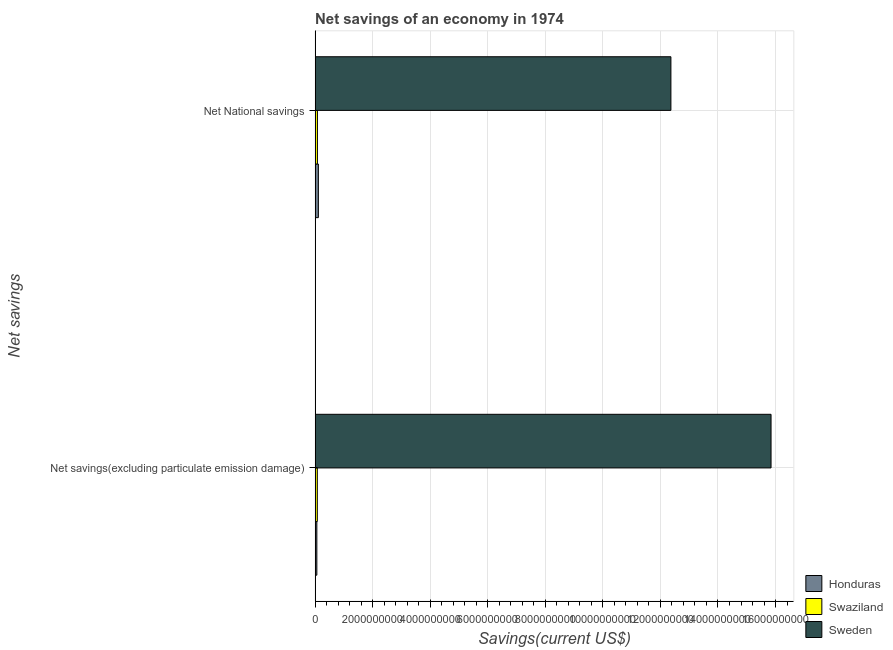Are the number of bars on each tick of the Y-axis equal?
Offer a very short reply. Yes. How many bars are there on the 1st tick from the top?
Provide a short and direct response. 3. How many bars are there on the 1st tick from the bottom?
Make the answer very short. 3. What is the label of the 1st group of bars from the top?
Give a very brief answer. Net National savings. What is the net national savings in Sweden?
Provide a succinct answer. 1.24e+1. Across all countries, what is the maximum net national savings?
Offer a terse response. 1.24e+1. Across all countries, what is the minimum net savings(excluding particulate emission damage)?
Offer a very short reply. 6.03e+07. In which country was the net national savings minimum?
Ensure brevity in your answer.  Swaziland. What is the total net savings(excluding particulate emission damage) in the graph?
Offer a very short reply. 1.60e+1. What is the difference between the net national savings in Honduras and that in Swaziland?
Provide a succinct answer. 3.31e+07. What is the difference between the net national savings in Honduras and the net savings(excluding particulate emission damage) in Sweden?
Your answer should be very brief. -1.57e+1. What is the average net national savings per country?
Provide a succinct answer. 4.19e+09. What is the difference between the net savings(excluding particulate emission damage) and net national savings in Swaziland?
Your response must be concise. -4.00e+06. In how many countries, is the net savings(excluding particulate emission damage) greater than 11600000000 US$?
Your answer should be very brief. 1. What is the ratio of the net savings(excluding particulate emission damage) in Honduras to that in Swaziland?
Your response must be concise. 0.79. Is the net national savings in Honduras less than that in Sweden?
Ensure brevity in your answer.  Yes. In how many countries, is the net savings(excluding particulate emission damage) greater than the average net savings(excluding particulate emission damage) taken over all countries?
Keep it short and to the point. 1. What does the 2nd bar from the top in Net National savings represents?
Give a very brief answer. Swaziland. What does the 2nd bar from the bottom in Net National savings represents?
Give a very brief answer. Swaziland. Are all the bars in the graph horizontal?
Provide a succinct answer. Yes. Are the values on the major ticks of X-axis written in scientific E-notation?
Ensure brevity in your answer.  No. Where does the legend appear in the graph?
Keep it short and to the point. Bottom right. What is the title of the graph?
Keep it short and to the point. Net savings of an economy in 1974. Does "Nigeria" appear as one of the legend labels in the graph?
Your answer should be compact. No. What is the label or title of the X-axis?
Ensure brevity in your answer.  Savings(current US$). What is the label or title of the Y-axis?
Your answer should be very brief. Net savings. What is the Savings(current US$) of Honduras in Net savings(excluding particulate emission damage)?
Provide a short and direct response. 6.03e+07. What is the Savings(current US$) in Swaziland in Net savings(excluding particulate emission damage)?
Your answer should be compact. 7.66e+07. What is the Savings(current US$) of Sweden in Net savings(excluding particulate emission damage)?
Your answer should be compact. 1.58e+1. What is the Savings(current US$) in Honduras in Net National savings?
Your answer should be compact. 1.14e+08. What is the Savings(current US$) in Swaziland in Net National savings?
Provide a short and direct response. 8.06e+07. What is the Savings(current US$) of Sweden in Net National savings?
Give a very brief answer. 1.24e+1. Across all Net savings, what is the maximum Savings(current US$) of Honduras?
Your answer should be very brief. 1.14e+08. Across all Net savings, what is the maximum Savings(current US$) of Swaziland?
Give a very brief answer. 8.06e+07. Across all Net savings, what is the maximum Savings(current US$) of Sweden?
Your answer should be very brief. 1.58e+1. Across all Net savings, what is the minimum Savings(current US$) of Honduras?
Make the answer very short. 6.03e+07. Across all Net savings, what is the minimum Savings(current US$) in Swaziland?
Make the answer very short. 7.66e+07. Across all Net savings, what is the minimum Savings(current US$) in Sweden?
Keep it short and to the point. 1.24e+1. What is the total Savings(current US$) of Honduras in the graph?
Provide a short and direct response. 1.74e+08. What is the total Savings(current US$) of Swaziland in the graph?
Offer a terse response. 1.57e+08. What is the total Savings(current US$) in Sweden in the graph?
Your answer should be compact. 2.82e+1. What is the difference between the Savings(current US$) of Honduras in Net savings(excluding particulate emission damage) and that in Net National savings?
Your answer should be very brief. -5.34e+07. What is the difference between the Savings(current US$) of Swaziland in Net savings(excluding particulate emission damage) and that in Net National savings?
Ensure brevity in your answer.  -4.00e+06. What is the difference between the Savings(current US$) of Sweden in Net savings(excluding particulate emission damage) and that in Net National savings?
Provide a short and direct response. 3.48e+09. What is the difference between the Savings(current US$) of Honduras in Net savings(excluding particulate emission damage) and the Savings(current US$) of Swaziland in Net National savings?
Your response must be concise. -2.03e+07. What is the difference between the Savings(current US$) of Honduras in Net savings(excluding particulate emission damage) and the Savings(current US$) of Sweden in Net National savings?
Keep it short and to the point. -1.23e+1. What is the difference between the Savings(current US$) in Swaziland in Net savings(excluding particulate emission damage) and the Savings(current US$) in Sweden in Net National savings?
Provide a short and direct response. -1.23e+1. What is the average Savings(current US$) of Honduras per Net savings?
Offer a very short reply. 8.70e+07. What is the average Savings(current US$) of Swaziland per Net savings?
Keep it short and to the point. 7.86e+07. What is the average Savings(current US$) in Sweden per Net savings?
Keep it short and to the point. 1.41e+1. What is the difference between the Savings(current US$) of Honduras and Savings(current US$) of Swaziland in Net savings(excluding particulate emission damage)?
Provide a succinct answer. -1.63e+07. What is the difference between the Savings(current US$) of Honduras and Savings(current US$) of Sweden in Net savings(excluding particulate emission damage)?
Offer a terse response. -1.58e+1. What is the difference between the Savings(current US$) of Swaziland and Savings(current US$) of Sweden in Net savings(excluding particulate emission damage)?
Your answer should be compact. -1.58e+1. What is the difference between the Savings(current US$) in Honduras and Savings(current US$) in Swaziland in Net National savings?
Ensure brevity in your answer.  3.31e+07. What is the difference between the Savings(current US$) of Honduras and Savings(current US$) of Sweden in Net National savings?
Ensure brevity in your answer.  -1.23e+1. What is the difference between the Savings(current US$) in Swaziland and Savings(current US$) in Sweden in Net National savings?
Make the answer very short. -1.23e+1. What is the ratio of the Savings(current US$) in Honduras in Net savings(excluding particulate emission damage) to that in Net National savings?
Provide a succinct answer. 0.53. What is the ratio of the Savings(current US$) in Swaziland in Net savings(excluding particulate emission damage) to that in Net National savings?
Your answer should be very brief. 0.95. What is the ratio of the Savings(current US$) in Sweden in Net savings(excluding particulate emission damage) to that in Net National savings?
Provide a succinct answer. 1.28. What is the difference between the highest and the second highest Savings(current US$) of Honduras?
Your response must be concise. 5.34e+07. What is the difference between the highest and the second highest Savings(current US$) of Swaziland?
Provide a short and direct response. 4.00e+06. What is the difference between the highest and the second highest Savings(current US$) of Sweden?
Make the answer very short. 3.48e+09. What is the difference between the highest and the lowest Savings(current US$) of Honduras?
Offer a very short reply. 5.34e+07. What is the difference between the highest and the lowest Savings(current US$) in Swaziland?
Your response must be concise. 4.00e+06. What is the difference between the highest and the lowest Savings(current US$) of Sweden?
Make the answer very short. 3.48e+09. 